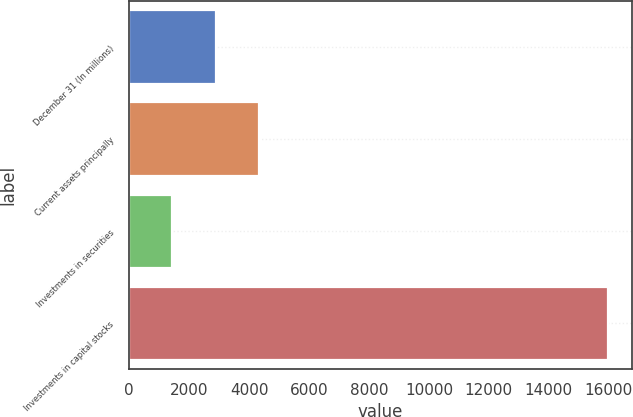<chart> <loc_0><loc_0><loc_500><loc_500><bar_chart><fcel>December 31 (In millions)<fcel>Current assets principally<fcel>Investments in securities<fcel>Investments in capital stocks<nl><fcel>2892.5<fcel>4346<fcel>1439<fcel>15974<nl></chart> 